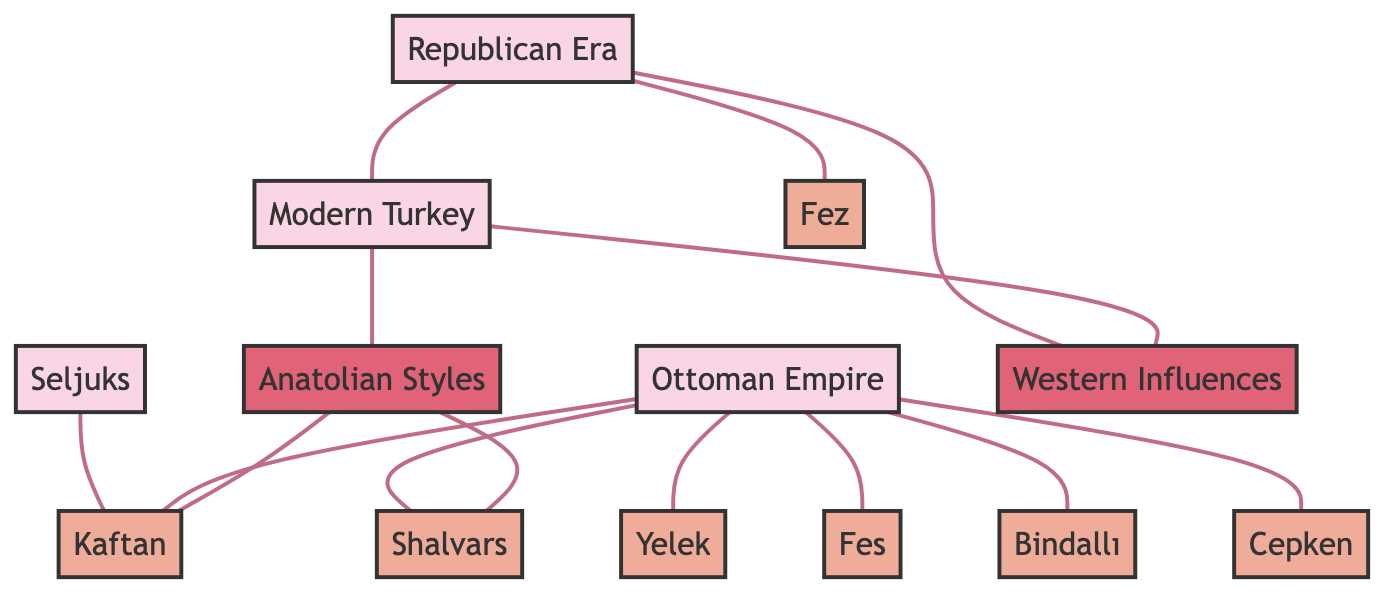What garment is associated with the Seljuks? The diagram shows a direct connection between the Seljuks and the Kaftan, indicating that the Kaftan is the garment associated with them.
Answer: Kaftan How many garments are linked to the Ottoman Empire? The Ottoman Empire has connections to seven garments as seen in the diagram, which are Kaftan, Yelek, Fes, Shalvars, Bindalli, and Cepken.
Answer: 7 Which era is linked to Western Influences? The Republican Era is connected to Western Influences according to the diagram, indicating the association between these two.
Answer: Republican Era What is the connection between Modern Turkey and Anatolian Styles? The diagram clearly shows a connection between Modern Turkey and Anatolian Styles, indicating that they are linked.
Answer: Connected Which two garments are directly associated with Anatolian Styles? The diagram indicates that Anatolian Styles has direct connections to Kaftan and Shalvars, meaning these garments are associated with it.
Answer: Kaftan, Shalvars What is the total number of nodes in the diagram? Counting all the unique nodes listed in the diagram, there are a total of thirteen distinct nodes.
Answer: 13 List the eras shown in the diagram. The diagram contains four eras: Seljuks, Ottoman Empire, Republican Era, and Modern Turkey.
Answer: Seljuks, Ottoman Empire, Republican Era, Modern Turkey Which garment is specifically noted to have Western Influences? The Fes is directly linked to Western Influences in the diagram, indicating this particular garment's association.
Answer: Fes Which node connects the Republican Era and Modern Turkey? The diagram shows a direct connection from the Republican Era to Modern Turkey, indicating they are directly linked to each other.
Answer: Directly connected 